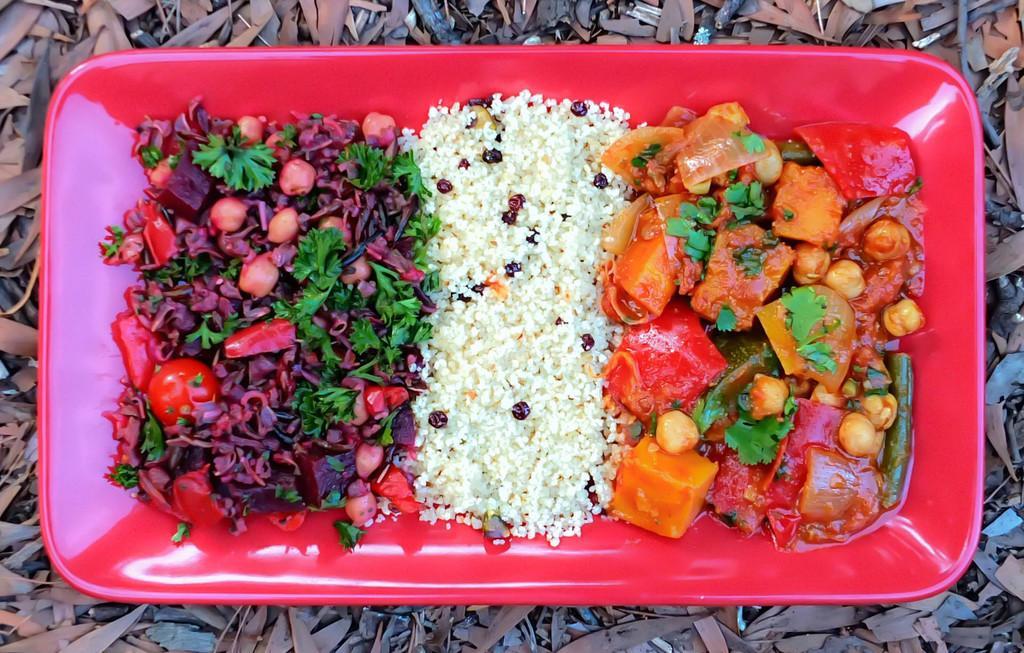Could you give a brief overview of what you see in this image? This image consists of food kept in a plate. The plate is in red color. At the bottom, there are dry leaves and small stems on the ground. 